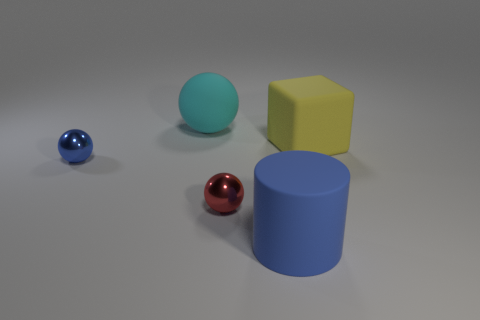What is the shape of the thing that is to the left of the red shiny object and on the right side of the small blue sphere?
Keep it short and to the point. Sphere. Is there anything else that is the same size as the red metallic sphere?
Give a very brief answer. Yes. What is the color of the cylinder that is right of the small sphere to the right of the big matte ball?
Offer a terse response. Blue. The object to the left of the large object behind the yellow block that is behind the small blue shiny object is what shape?
Provide a succinct answer. Sphere. What is the size of the ball that is both behind the small red metal object and in front of the rubber ball?
Your response must be concise. Small. What number of matte objects are the same color as the rubber block?
Offer a very short reply. 0. What is the material of the small object that is the same color as the large rubber cylinder?
Offer a terse response. Metal. What is the blue sphere made of?
Ensure brevity in your answer.  Metal. Is the material of the tiny ball in front of the blue metal sphere the same as the big yellow object?
Make the answer very short. No. There is a large rubber object that is on the right side of the cylinder; what is its shape?
Provide a short and direct response. Cube. 